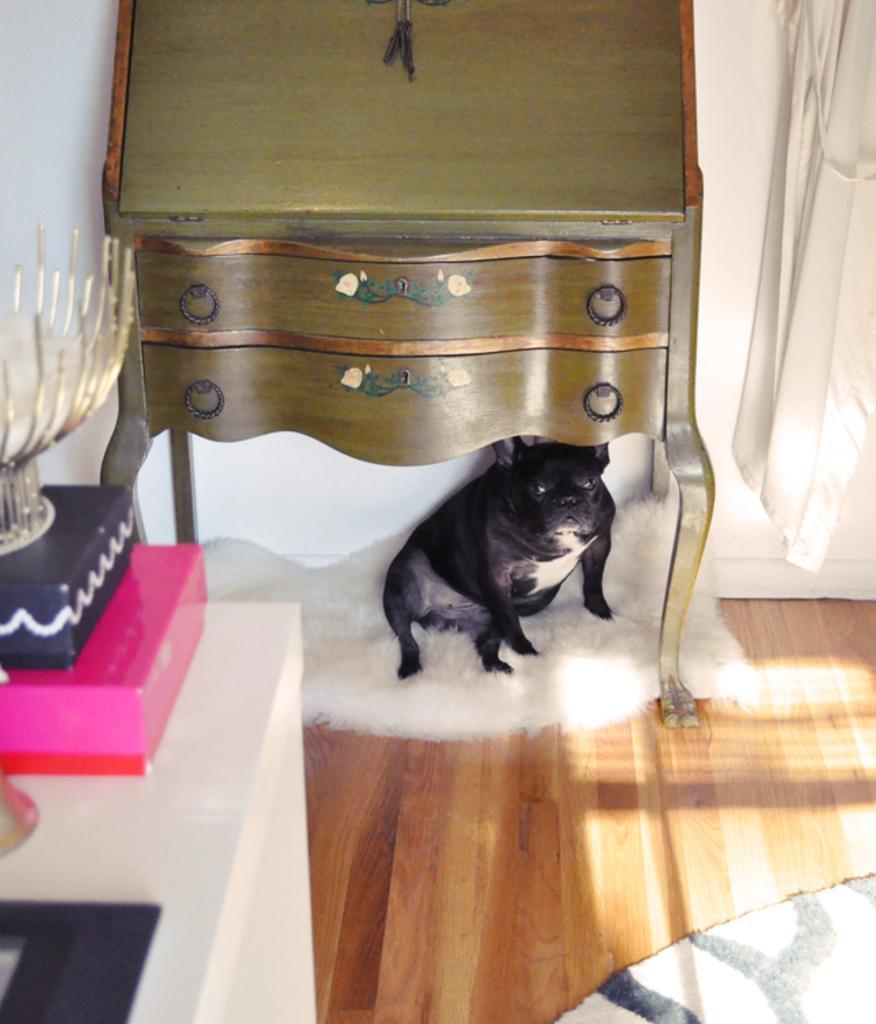How would you summarize this image in a sentence or two? In the photo there is a dog on a carpet under a table. There is a curtain beside the table and the floor is made of maple wood. There is table with bowl and boxes on left side front corner. 